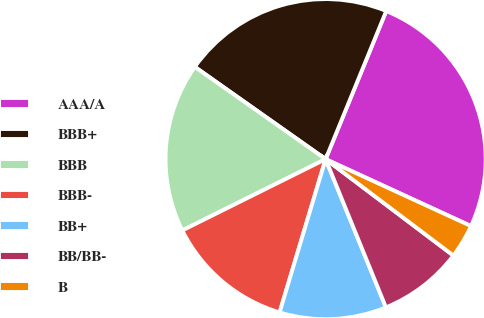Convert chart to OTSL. <chart><loc_0><loc_0><loc_500><loc_500><pie_chart><fcel>AAA/A<fcel>BBB+<fcel>BBB<fcel>BBB-<fcel>BB+<fcel>BB/BB-<fcel>B<nl><fcel>25.68%<fcel>21.4%<fcel>17.12%<fcel>13.01%<fcel>10.79%<fcel>8.56%<fcel>3.42%<nl></chart> 